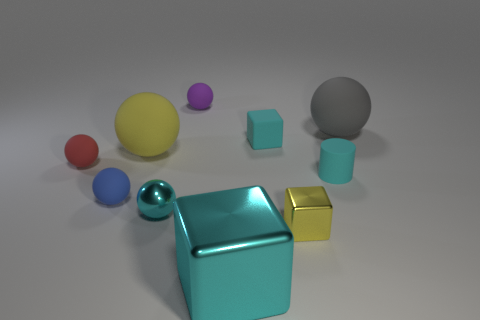Subtract 2 spheres. How many spheres are left? 4 Subtract all gray balls. How many balls are left? 5 Subtract all large gray matte spheres. How many spheres are left? 5 Subtract all yellow spheres. Subtract all green cubes. How many spheres are left? 5 Subtract all balls. How many objects are left? 4 Add 2 large brown metallic cylinders. How many large brown metallic cylinders exist? 2 Subtract 1 yellow spheres. How many objects are left? 9 Subtract all tiny yellow metallic things. Subtract all big purple spheres. How many objects are left? 9 Add 1 cyan balls. How many cyan balls are left? 2 